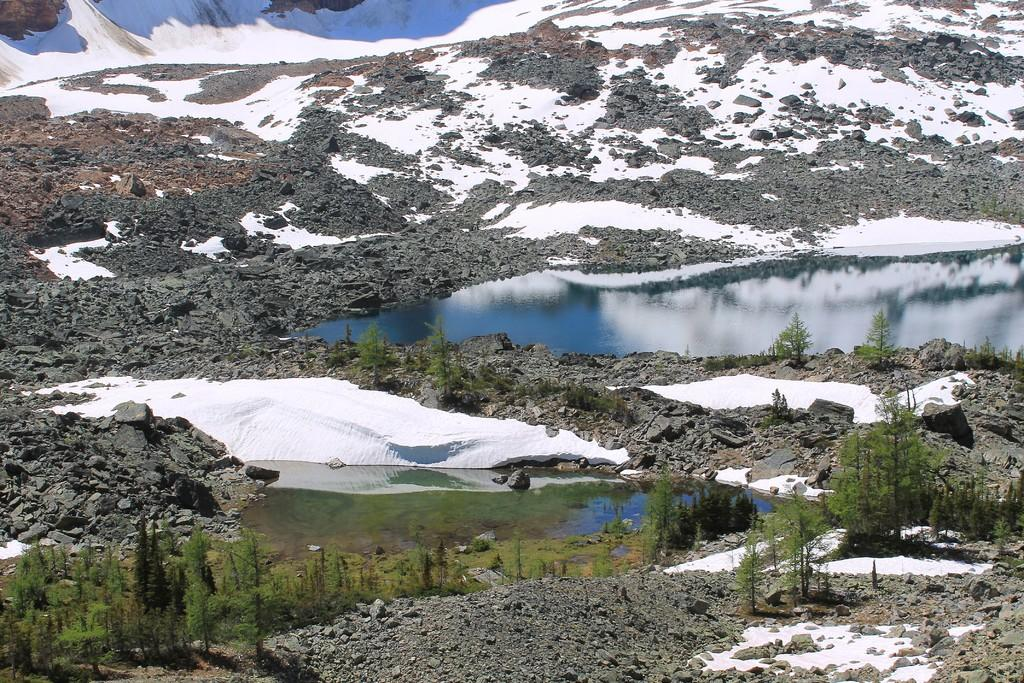What type of vegetation can be seen in the image? There are trees in the image. What other objects or features can be seen in the image? There are stones and water visible in the image. What is located at the top of the image? There are hills at the top of the image. What type of plant is growing next to the cactus in the image? There is no cactus present in the image, so it is not possible to answer that question. 